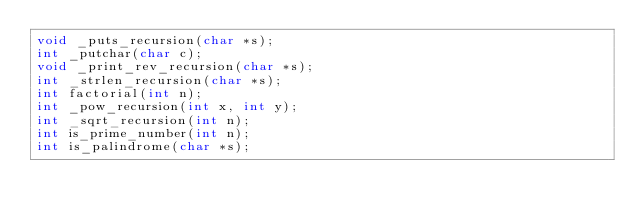<code> <loc_0><loc_0><loc_500><loc_500><_C_>void _puts_recursion(char *s);
int _putchar(char c);
void _print_rev_recursion(char *s);
int _strlen_recursion(char *s);
int factorial(int n);
int _pow_recursion(int x, int y);
int _sqrt_recursion(int n);
int is_prime_number(int n);
int is_palindrome(char *s);
</code> 